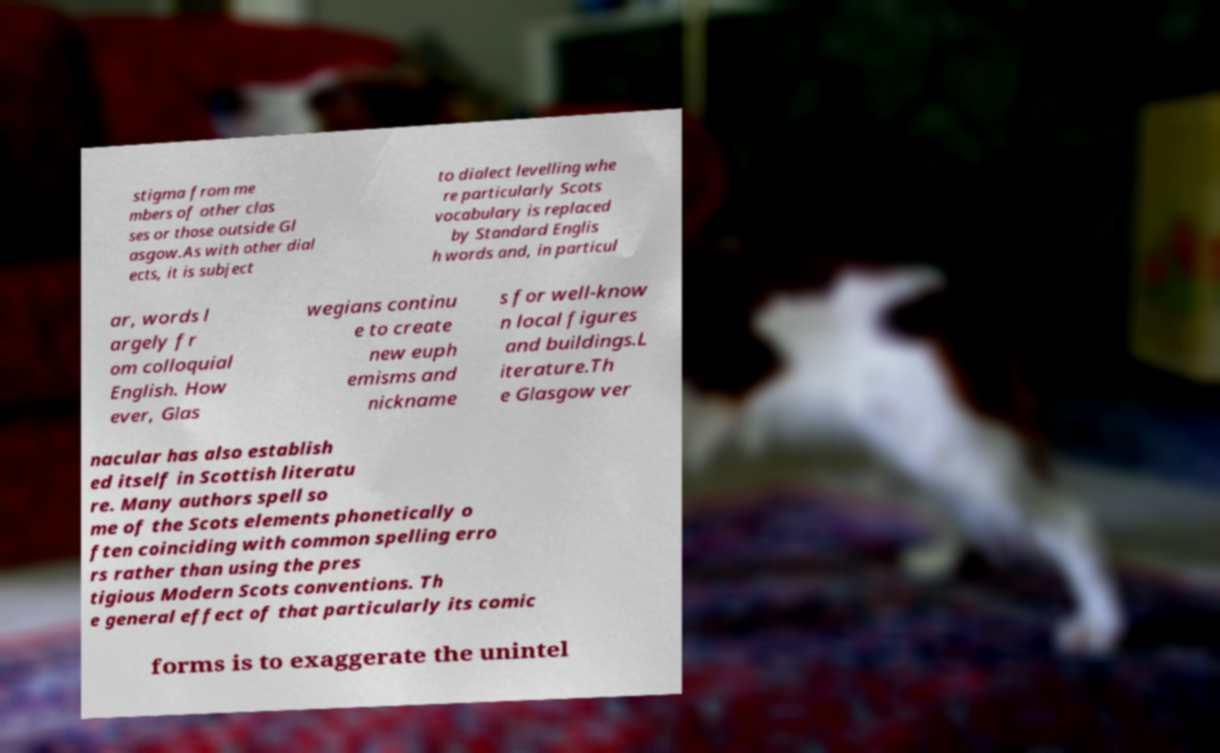Could you extract and type out the text from this image? stigma from me mbers of other clas ses or those outside Gl asgow.As with other dial ects, it is subject to dialect levelling whe re particularly Scots vocabulary is replaced by Standard Englis h words and, in particul ar, words l argely fr om colloquial English. How ever, Glas wegians continu e to create new euph emisms and nickname s for well-know n local figures and buildings.L iterature.Th e Glasgow ver nacular has also establish ed itself in Scottish literatu re. Many authors spell so me of the Scots elements phonetically o ften coinciding with common spelling erro rs rather than using the pres tigious Modern Scots conventions. Th e general effect of that particularly its comic forms is to exaggerate the unintel 